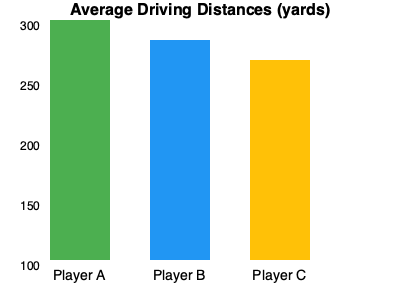Based on the bar chart showing the average driving distances of top Alps Tour players, what is the approximate difference in yards between the longest and shortest hitters? To find the difference between the longest and shortest hitters, we need to:

1. Identify the longest hitter: Player A (tallest bar)
2. Identify the shortest hitter: Player C (shortest bar)
3. Estimate their distances:
   - Player A: approximately 300 yards
   - Player C: approximately 260 yards
4. Calculate the difference:
   $300 - 260 = 40$ yards

The difference between the longest and shortest hitters is about 40 yards.
Answer: 40 yards 